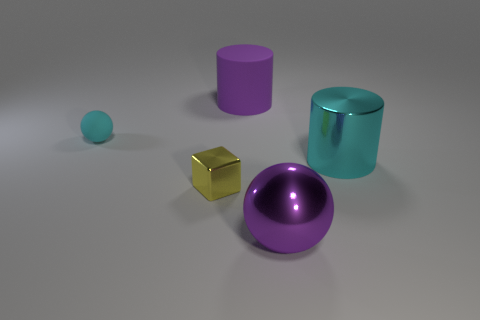Add 2 small yellow metal things. How many objects exist? 7 Subtract all cylinders. How many objects are left? 3 Subtract 0 green blocks. How many objects are left? 5 Subtract all tiny metallic balls. Subtract all small matte spheres. How many objects are left? 4 Add 3 purple metal balls. How many purple metal balls are left? 4 Add 3 matte balls. How many matte balls exist? 4 